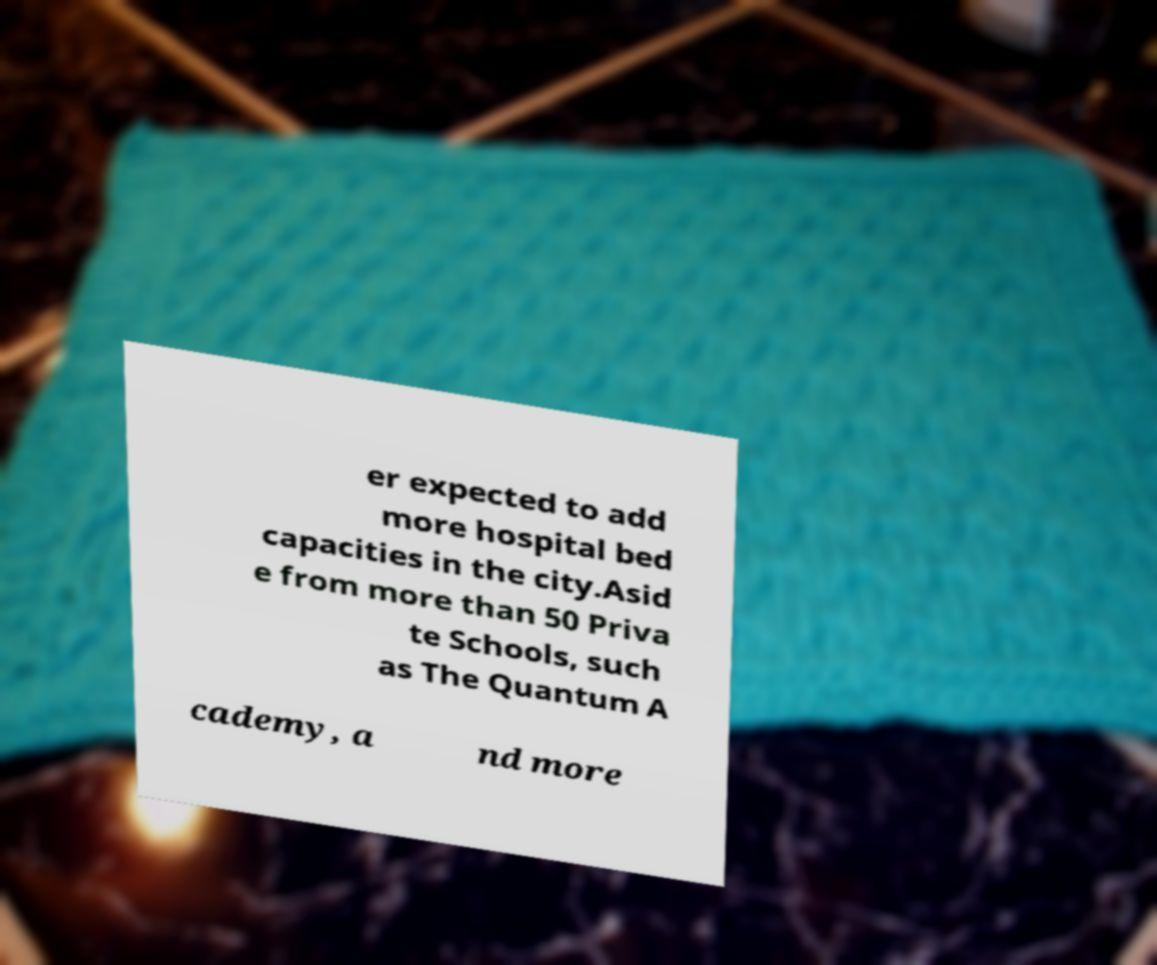Please read and relay the text visible in this image. What does it say? er expected to add more hospital bed capacities in the city.Asid e from more than 50 Priva te Schools, such as The Quantum A cademy, a nd more 